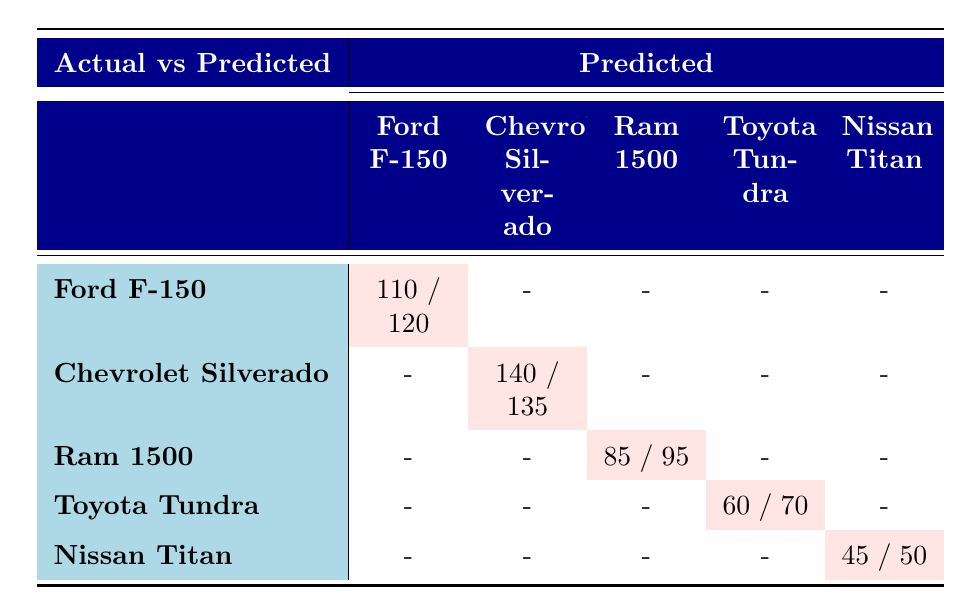What is the predicted number of purchases for the Ford F-150? The table shows that the predicted number of purchases for the Ford F-150 is 110.
Answer: 110 How many actual purchases were made for the Chevrolet Silverado? The table indicates that the actual number of purchases for the Chevrolet Silverado is 135.
Answer: 135 What is the total of actual purchases for Ram 1500 and Nissan Titan? Adding the actual purchases for Ram 1500 (95) and Nissan Titan (50) gives us 95 + 50 = 145.
Answer: 145 Is the prediction for the actual purchases of Toyota Tundra higher than the actual number? The predicted purchases for Toyota Tundra is 60, while the actual number is 70, so the prediction is not higher.
Answer: No Which truck model has the highest prediction for purchases? By comparing all predicted purchases, the Chevrolet Silverado has the highest predicted purchases at 140.
Answer: Chevrolet Silverado What is the difference between actual purchases and predicted purchases for the Nissan Titan? The table shows actual purchases for Nissan Titan at 50 and predicted at 45. The difference is 50 - 45 = 5.
Answer: 5 Which truck model had more actual purchases than predicted purchases? The table shows that Ford F-150 and Chevrolet Silverado both had actual purchases (120 and 135) greater than their predictions (110 and 140 respectively). Therefore, only Ford F-150 fits this condition.
Answer: Ford F-150 What percentage of the predicted purchases for the Ram 1500 were completed? Actual purchases for Ram 1500 are 95, predicted are 85. Therefore, the percentage is (85/95) * 100 = 89.47%.
Answer: 89.47% How many truck models had a discrepancy between actual purchases and predicted purchases? Looking at the table, Ford F-150, Chevrolet Silverado, and Ram 1500 all have discrepancies, totaling three truck models that show differences.
Answer: 3 